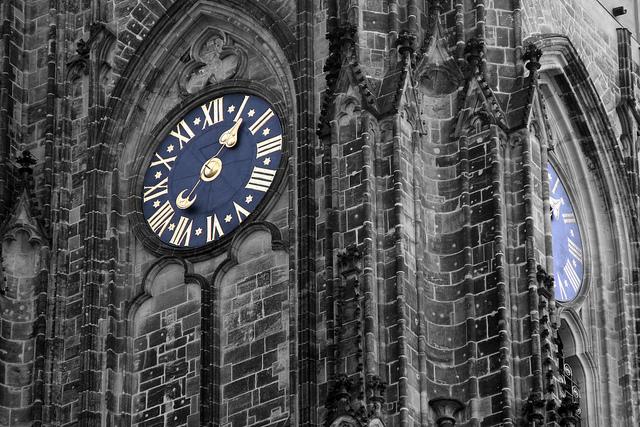What times does the clock have?
Keep it brief. 7:07. Is this an older building?
Keep it brief. Yes. Is this clock using Roman numerals?
Be succinct. Yes. What kind of architecture is the building?
Short answer required. Gothic. 